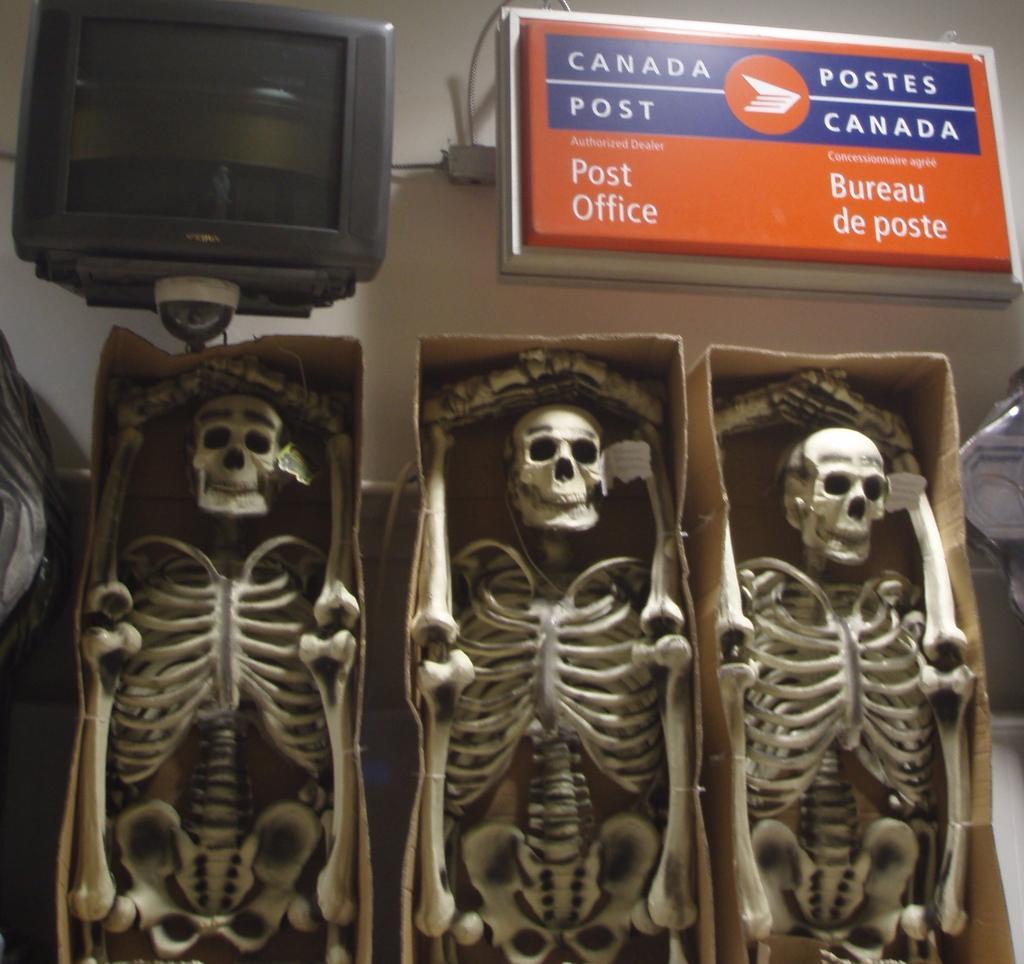Could you give a brief overview of what you see in this image? In this image we can see skeletons in the boxes, beside that we can see television and some text written on the board. 